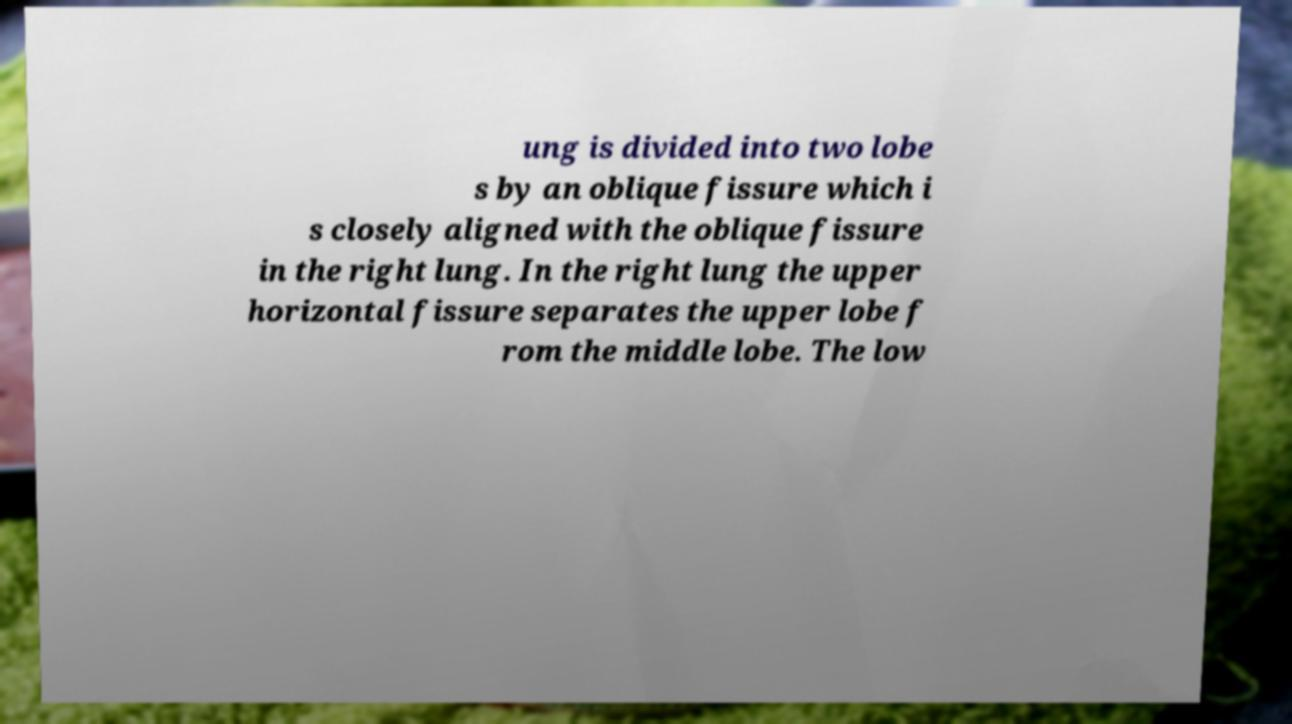Could you assist in decoding the text presented in this image and type it out clearly? ung is divided into two lobe s by an oblique fissure which i s closely aligned with the oblique fissure in the right lung. In the right lung the upper horizontal fissure separates the upper lobe f rom the middle lobe. The low 